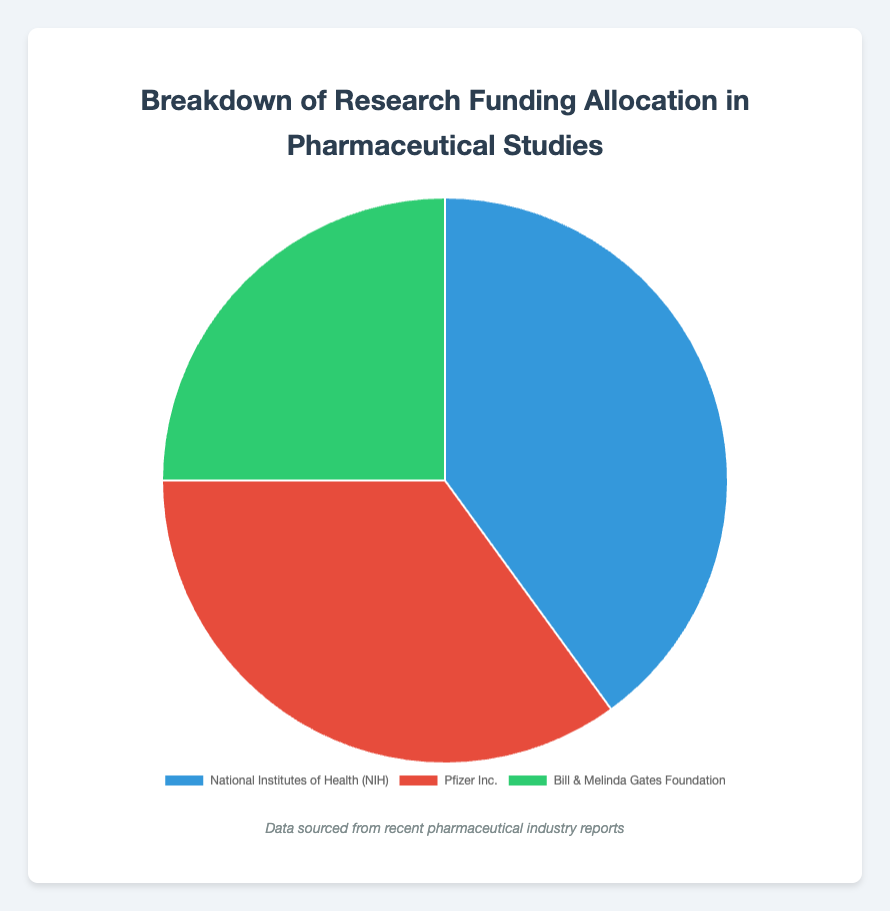Which entity has the highest percentage of research funding allocation? Look at the segments in the pie chart and identify which one is the largest. The largest segment corresponds to the National Institutes of Health (NIH) with 40%.
Answer: National Institutes of Health (NIH) What is the combined percentage of research funding allocation by Pfizer Inc. and Bill & Melinda Gates Foundation? Add the percentages allocated to Pfizer Inc. (35%) and Bill & Melinda Gates Foundation (25%). 35 + 25 = 60%.
Answer: 60% How much more funding does the National Institutes of Health (NIH) receive compared to the Bill & Melinda Gates Foundation in percentage points? Subtract the percentage allocated to the Bill & Melinda Gates Foundation (25%) from that of the NIH (40%). 40 - 25 = 15%.
Answer: 15% Which sector receives the least amount of research funding? Look at the smallest segment in the pie chart. The smallest segment corresponds to Non-Profits, represented by the Bill & Melinda Gates Foundation with 25%.
Answer: Non-Profits By how many percentage points does the funding allocation of the private sector (Pfizer Inc.) exceed that of non-profits (Bill & Melinda Gates Foundation)? Subtract the percentage allocated to the Bill & Melinda Gates Foundation (25%) from that of Pfizer Inc. (35%). 35 - 25 = 10%.
Answer: 10% What is the difference in funding allocation between the government (NIH) and the private sector (Pfizer Inc.)? Subtract the percentage allocated to Pfizer Inc. (35%) from that of the NIH (40%). 40 - 35 = 5%.
Answer: 5% What is the average percentage of research funding allocated across all entities shown? Sum all the percentages and divide by the number of entities: (40 + 35 + 25) / 3 = 100 / 3.
Answer: 33.33% If the total research funding is $100 million, how much funding in dollars does Pfizer Inc. receive? Multiply Pfizer Inc.'s percentage (35%) by the total funding amount: 0.35 * 100 million = 35 million dollars.
Answer: 35 million dollars Which entity's funding allocation is represented by the red segment in the pie chart? Identify the segment colored red on the pie chart, which is labeled as Pfizer Inc.
Answer: Pfizer Inc What fraction of the total research funding is allocated to non-profits (Bill & Melinda Gates Foundation)? Divide the percentage allocated to the Bill & Melinda Gates Foundation (25%) by 100 to convert it to a fraction: 25 / 100 = 1/4.
Answer: 1/4 